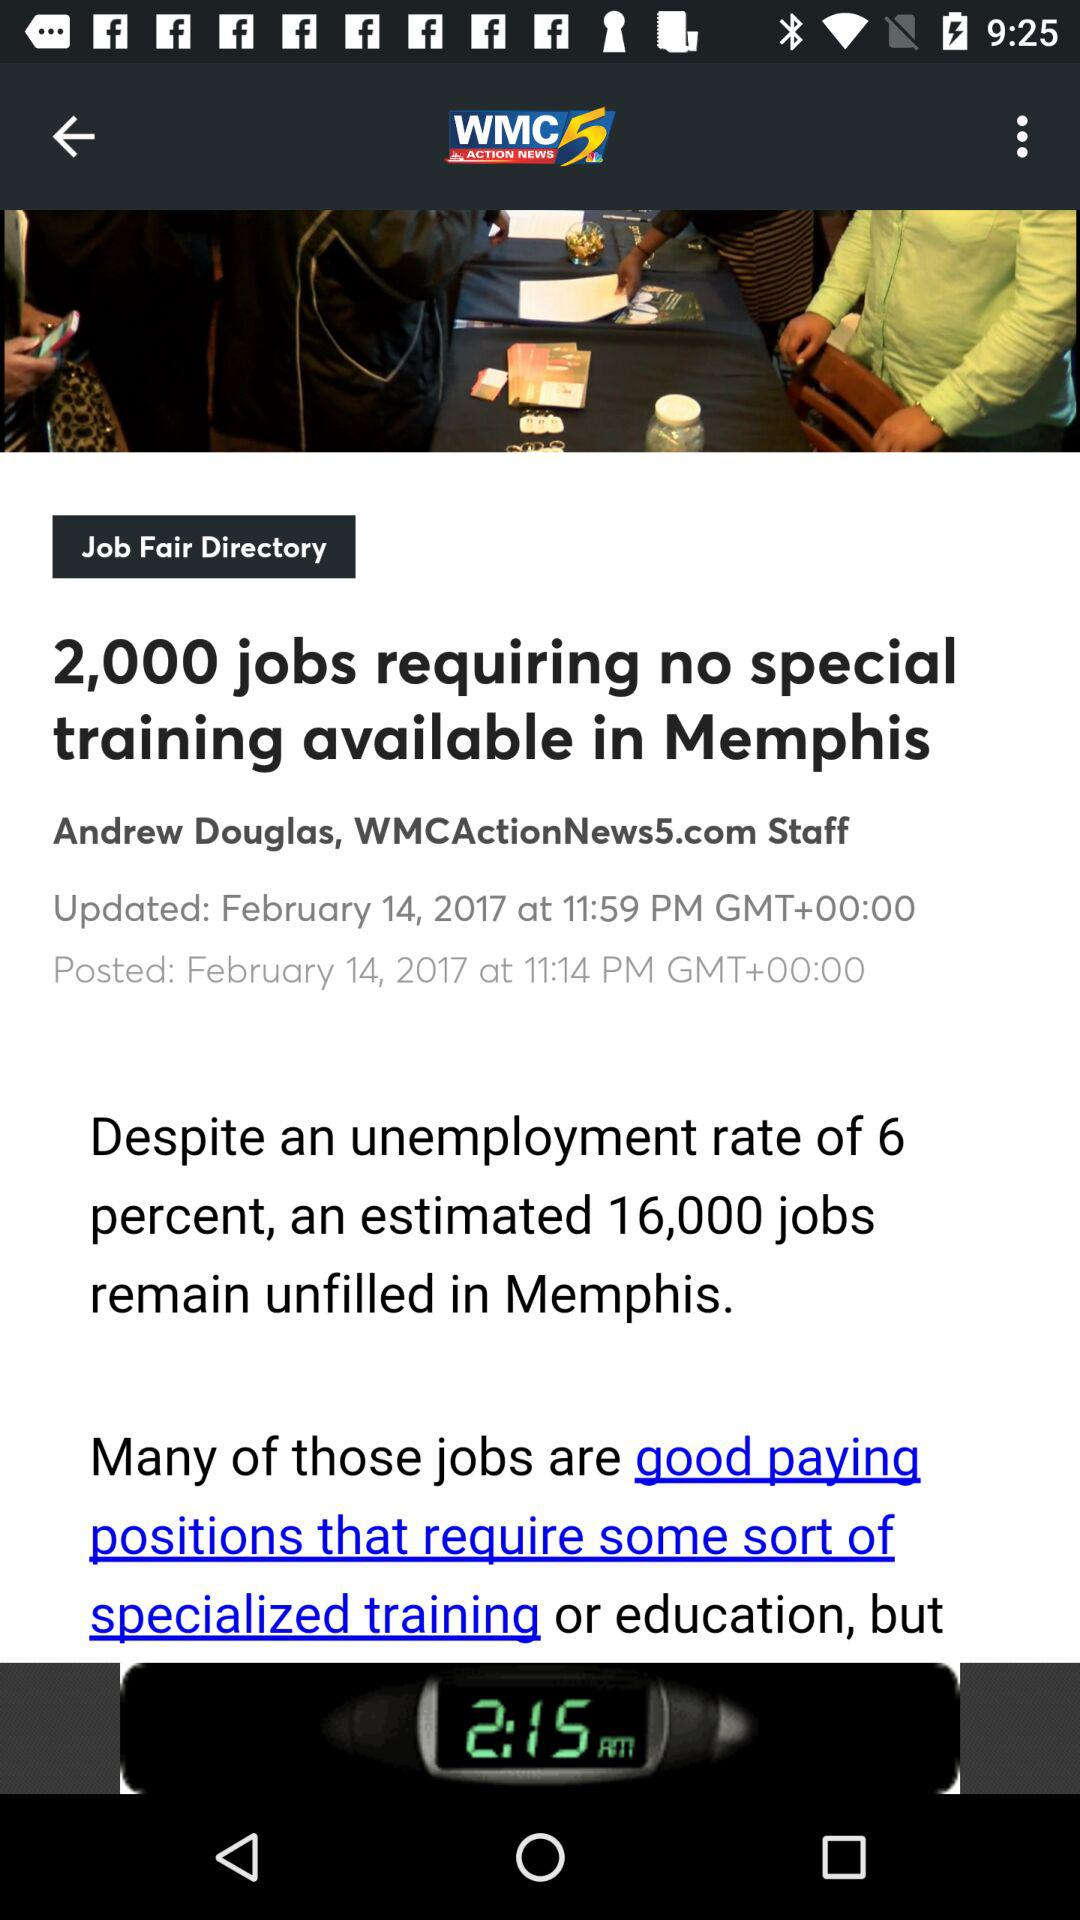What is the title of the article? The title of the article is "2,000 jobs requiring no special training available in Memphis". 